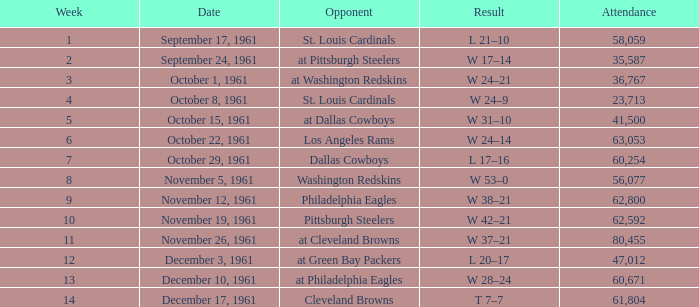During which week is there a game with an opponent for the washington redskins and more than 56,077 attendees? 0.0. 